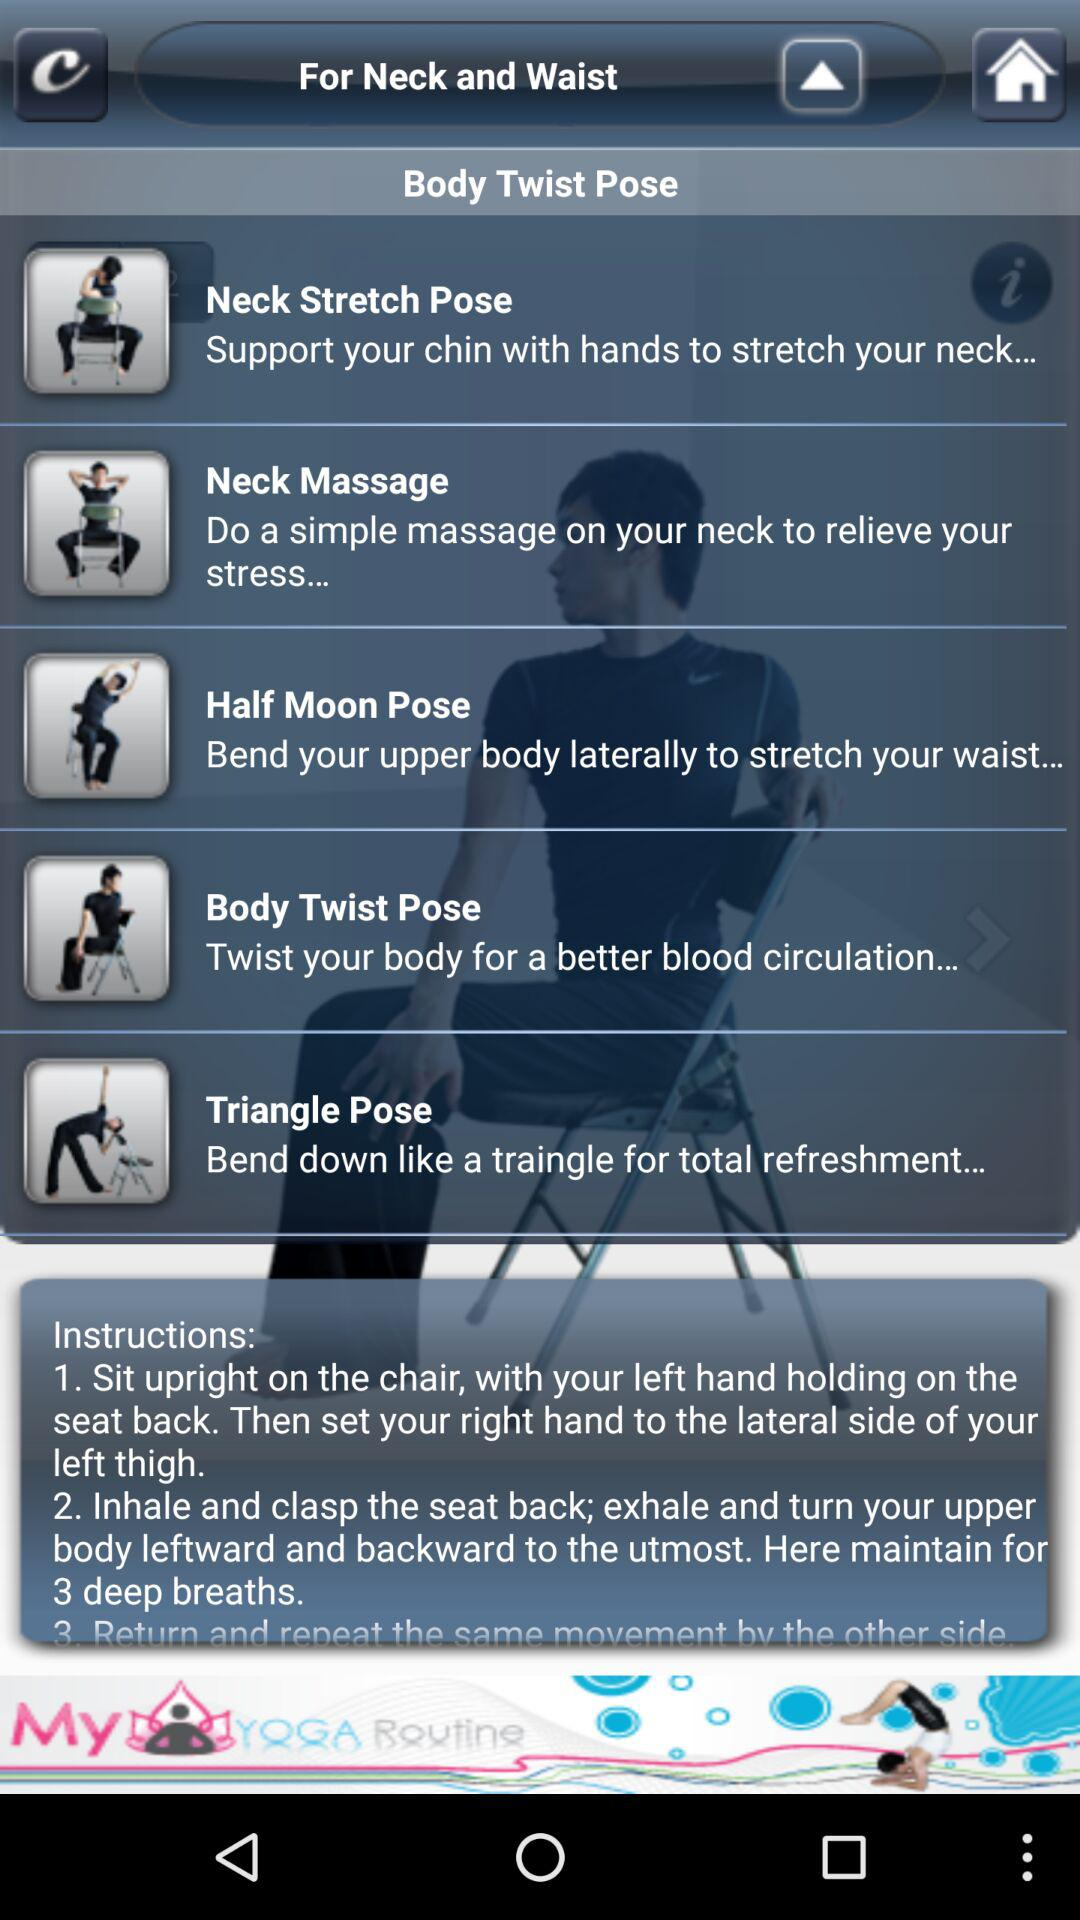Which pose is suitable for blood circulation? The pose that is suitable for blood circulation is "Body Twist Pose". 